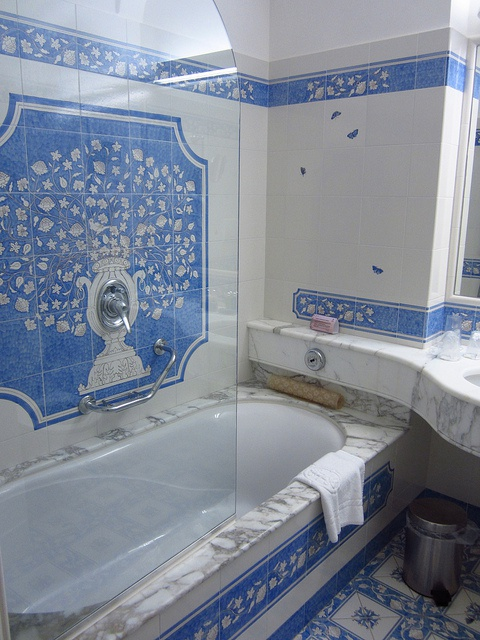Describe the objects in this image and their specific colors. I can see cup in darkgray, lightgray, and gray tones, cup in lightgray and darkgray tones, and sink in darkgray and lightgray tones in this image. 